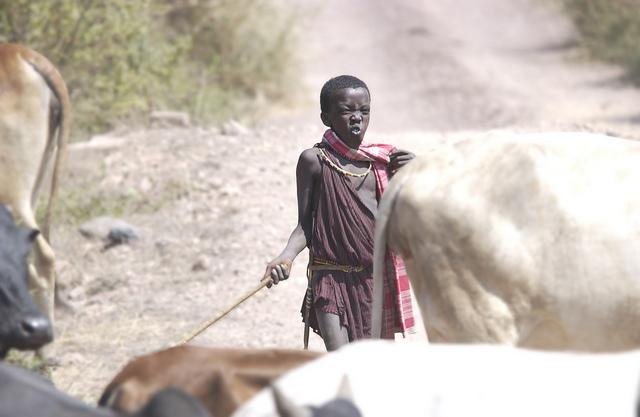What is this kid responsible for? Please explain your reasoning. herding cows. A young boy, squinting into the sun and dust, holds his prodding stick in his right hand as he tries to convince these cows to move along!. 